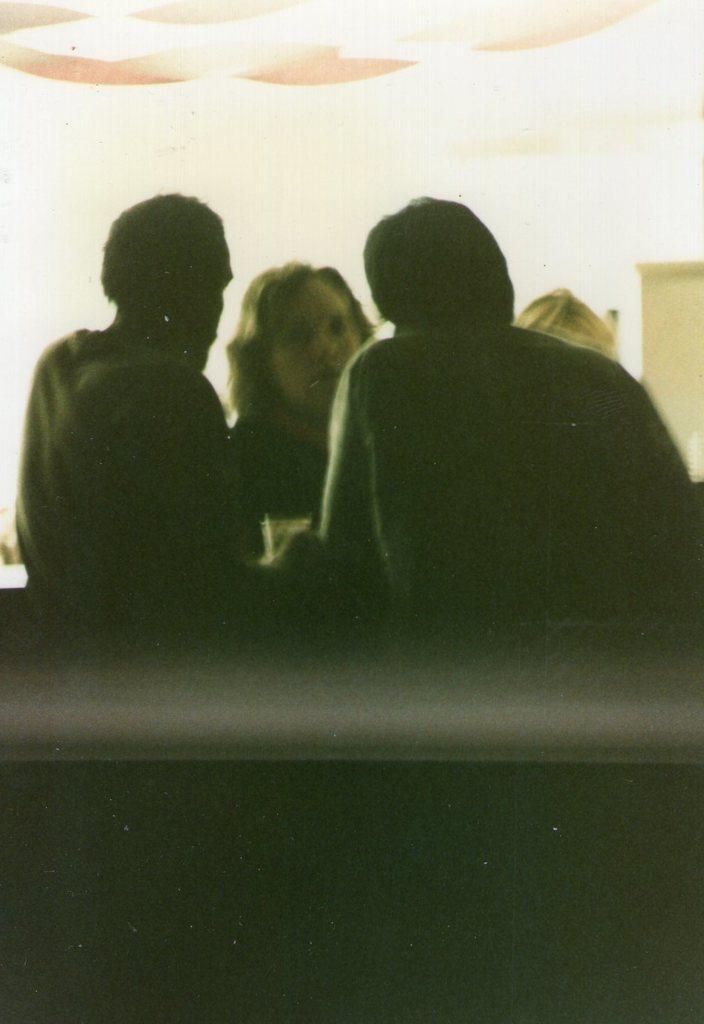Can you describe this image briefly? In the picture we can see some people standing near the desk and talking, in the background, we can see a wall with a door and to the ceiling we can see a light. 